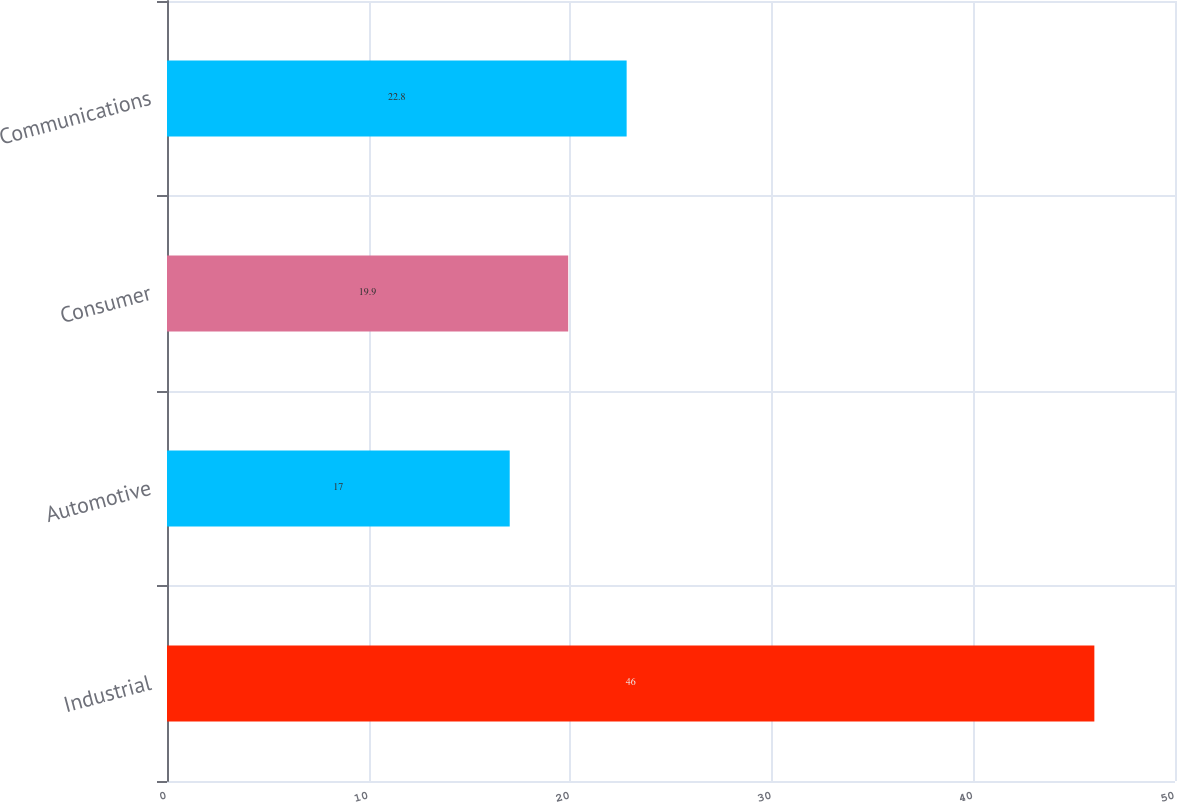<chart> <loc_0><loc_0><loc_500><loc_500><bar_chart><fcel>Industrial<fcel>Automotive<fcel>Consumer<fcel>Communications<nl><fcel>46<fcel>17<fcel>19.9<fcel>22.8<nl></chart> 